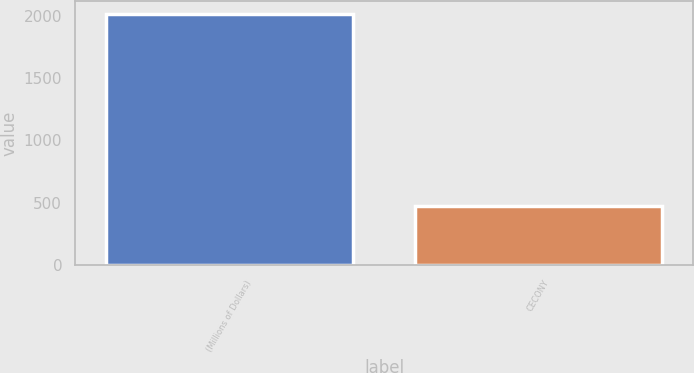Convert chart to OTSL. <chart><loc_0><loc_0><loc_500><loc_500><bar_chart><fcel>(Millions of Dollars)<fcel>CECONY<nl><fcel>2013<fcel>476<nl></chart> 